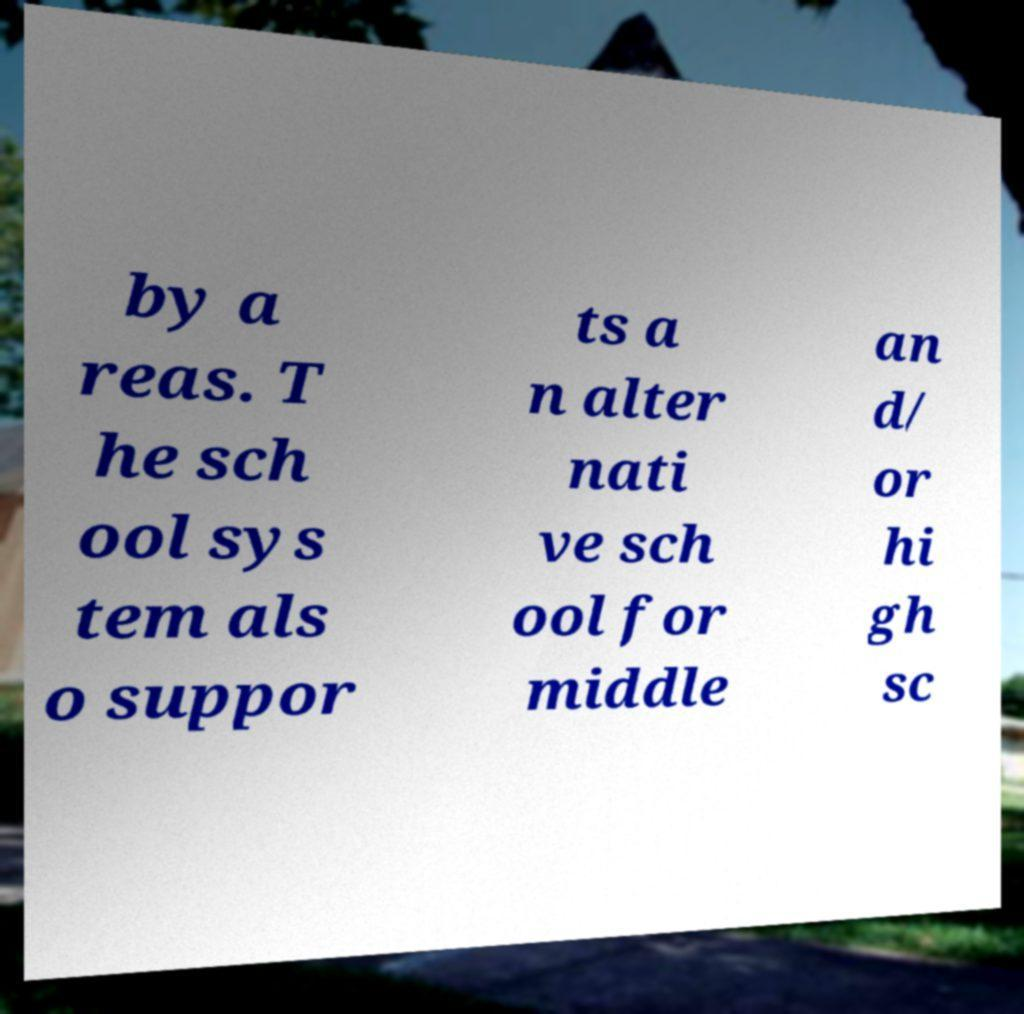There's text embedded in this image that I need extracted. Can you transcribe it verbatim? by a reas. T he sch ool sys tem als o suppor ts a n alter nati ve sch ool for middle an d/ or hi gh sc 